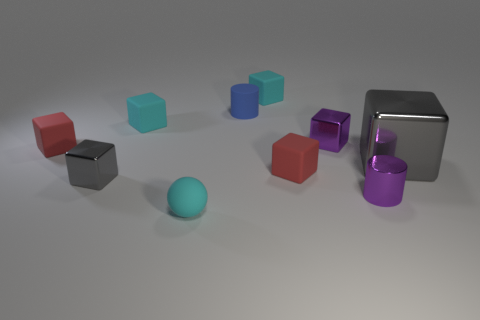There is a block in front of the tiny red block on the right side of the cyan rubber object that is in front of the purple cylinder; what is its color?
Offer a terse response. Gray. How many rubber objects are balls or large yellow balls?
Provide a short and direct response. 1. Are there more tiny shiny blocks right of the tiny sphere than tiny shiny cylinders to the left of the small purple metallic cylinder?
Ensure brevity in your answer.  Yes. What number of other objects are the same size as the blue matte object?
Offer a terse response. 8. There is a matte block behind the cyan block that is on the left side of the tiny cyan ball; how big is it?
Provide a succinct answer. Small. What number of small things are red things or gray shiny blocks?
Provide a short and direct response. 3. There is a cylinder that is on the right side of the red block on the right side of the small cyan object right of the blue thing; how big is it?
Your answer should be compact. Small. Are there any other things that are the same color as the rubber sphere?
Ensure brevity in your answer.  Yes. What material is the gray thing that is on the right side of the small cyan rubber thing that is in front of the gray block on the right side of the matte sphere made of?
Offer a terse response. Metal. Is the big gray thing the same shape as the tiny gray thing?
Give a very brief answer. Yes. 